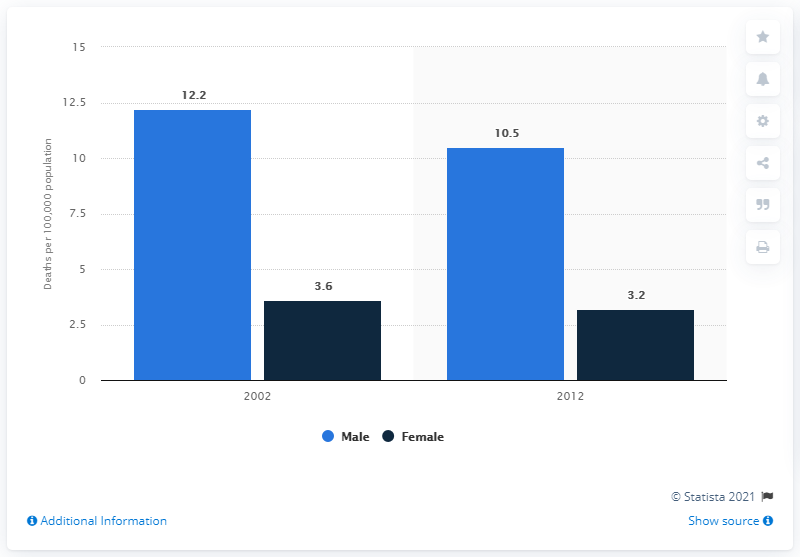Indicate a few pertinent items in this graphic. In 2002, there were approximately 12.2 deaths per 100,000 males in Japan that were caused by cirrhosis of the liver. 